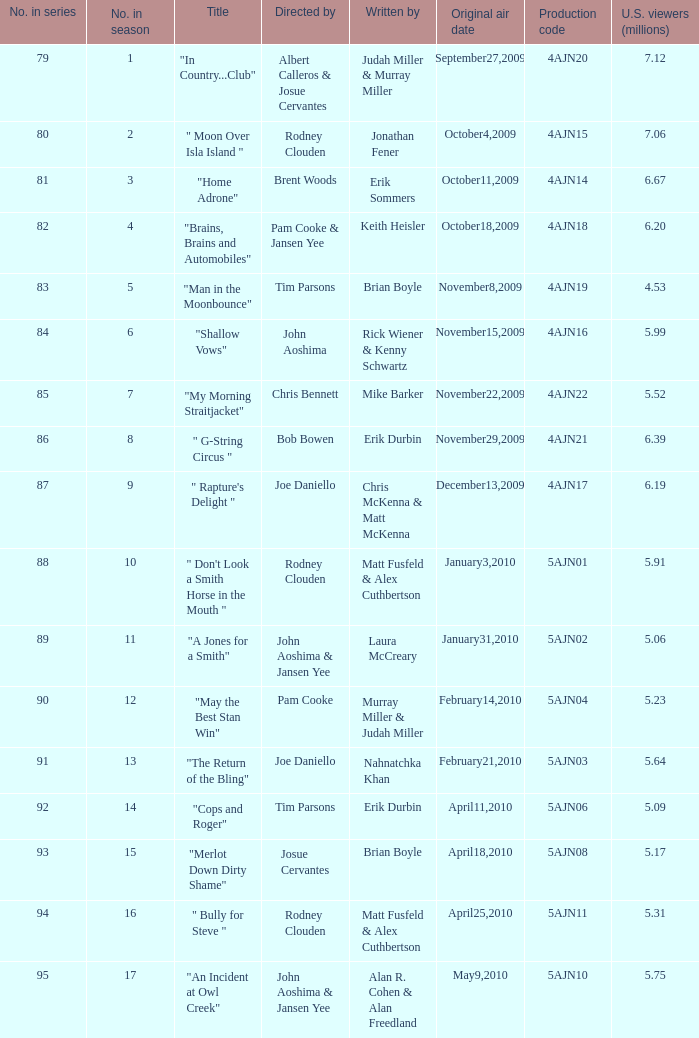Name who wrote number 88 Matt Fusfeld & Alex Cuthbertson. 